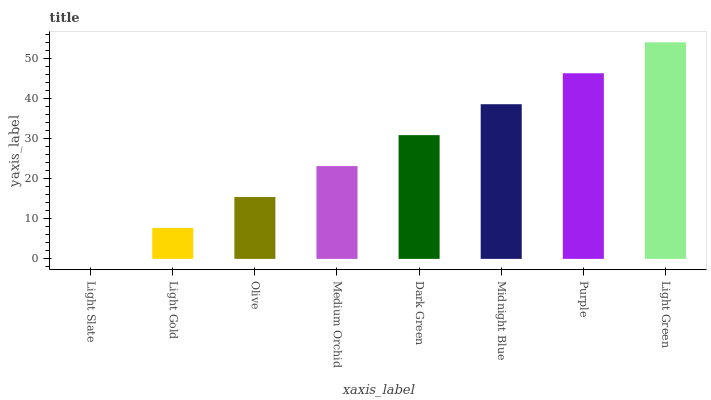Is Light Slate the minimum?
Answer yes or no. Yes. Is Light Green the maximum?
Answer yes or no. Yes. Is Light Gold the minimum?
Answer yes or no. No. Is Light Gold the maximum?
Answer yes or no. No. Is Light Gold greater than Light Slate?
Answer yes or no. Yes. Is Light Slate less than Light Gold?
Answer yes or no. Yes. Is Light Slate greater than Light Gold?
Answer yes or no. No. Is Light Gold less than Light Slate?
Answer yes or no. No. Is Dark Green the high median?
Answer yes or no. Yes. Is Medium Orchid the low median?
Answer yes or no. Yes. Is Medium Orchid the high median?
Answer yes or no. No. Is Dark Green the low median?
Answer yes or no. No. 